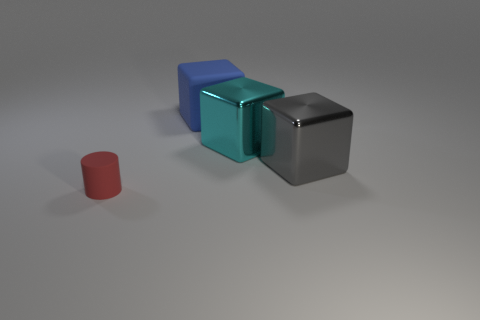Add 1 small green matte cubes. How many objects exist? 5 Subtract all cylinders. How many objects are left? 3 Subtract all matte blocks. Subtract all yellow rubber blocks. How many objects are left? 3 Add 4 large blocks. How many large blocks are left? 7 Add 2 small objects. How many small objects exist? 3 Subtract 1 gray blocks. How many objects are left? 3 